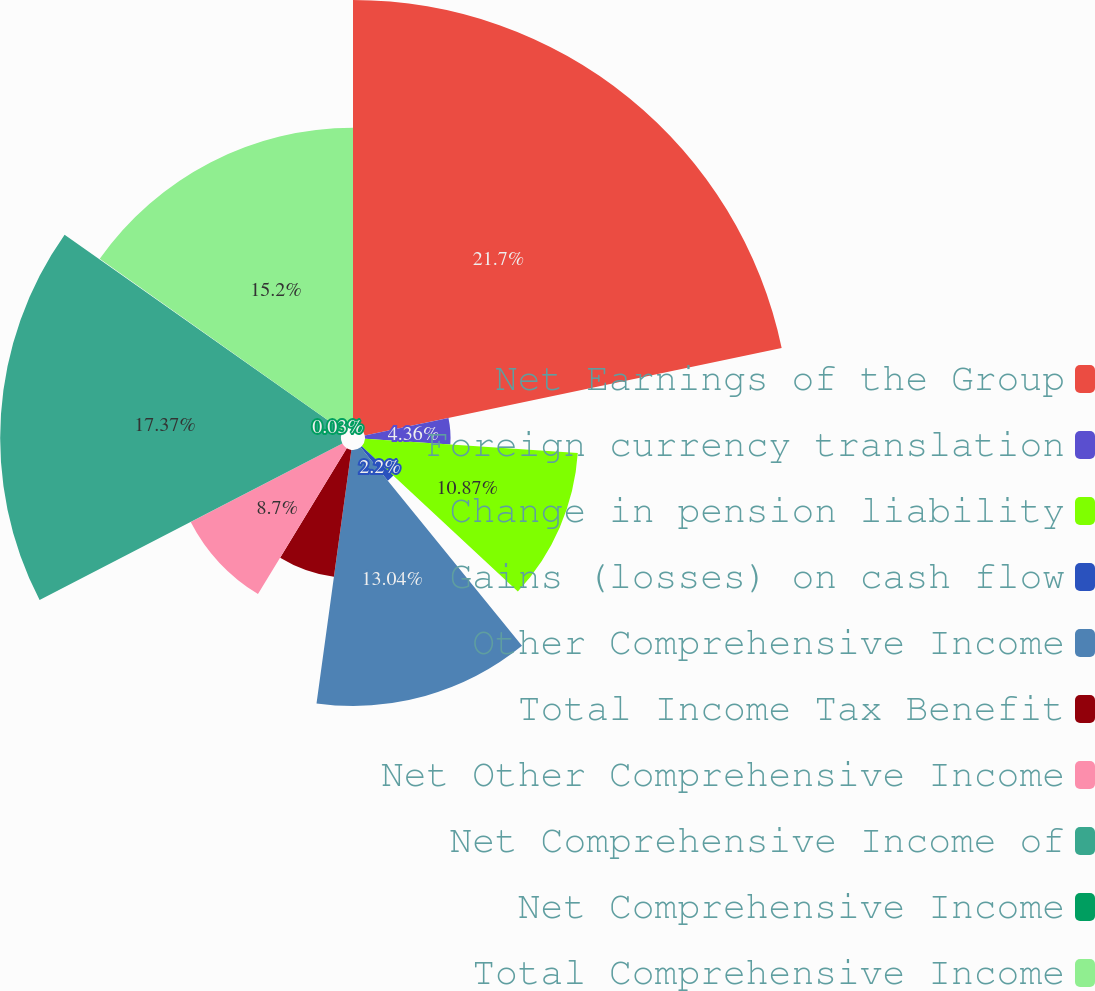Convert chart. <chart><loc_0><loc_0><loc_500><loc_500><pie_chart><fcel>Net Earnings of the Group<fcel>Foreign currency translation<fcel>Change in pension liability<fcel>Gains (losses) on cash flow<fcel>Other Comprehensive Income<fcel>Total Income Tax Benefit<fcel>Net Other Comprehensive Income<fcel>Net Comprehensive Income of<fcel>Net Comprehensive Income<fcel>Total Comprehensive Income<nl><fcel>21.71%<fcel>4.36%<fcel>10.87%<fcel>2.2%<fcel>13.04%<fcel>6.53%<fcel>8.7%<fcel>17.37%<fcel>0.03%<fcel>15.2%<nl></chart> 